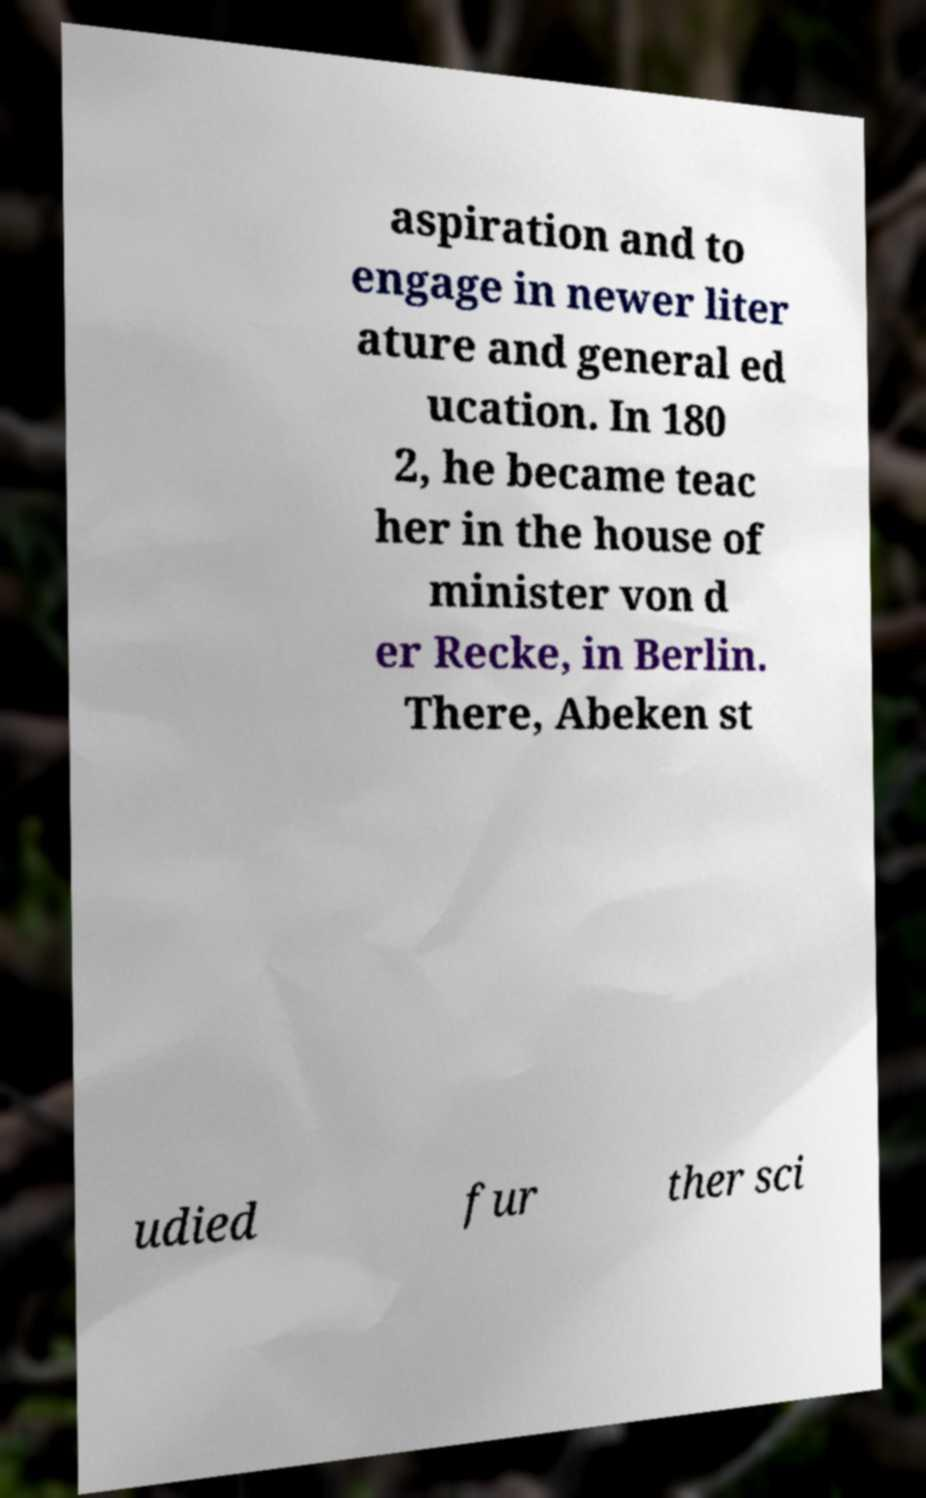Please read and relay the text visible in this image. What does it say? aspiration and to engage in newer liter ature and general ed ucation. In 180 2, he became teac her in the house of minister von d er Recke, in Berlin. There, Abeken st udied fur ther sci 